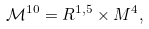<formula> <loc_0><loc_0><loc_500><loc_500>\mathcal { M } ^ { 1 0 } = R ^ { 1 , 5 } \times M ^ { 4 } ,</formula> 